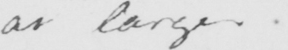Please provide the text content of this handwritten line. at large . 